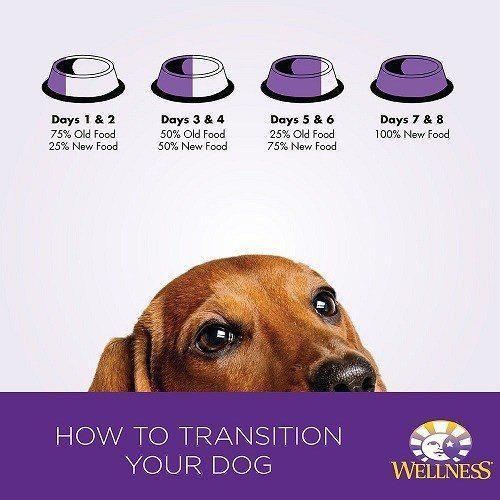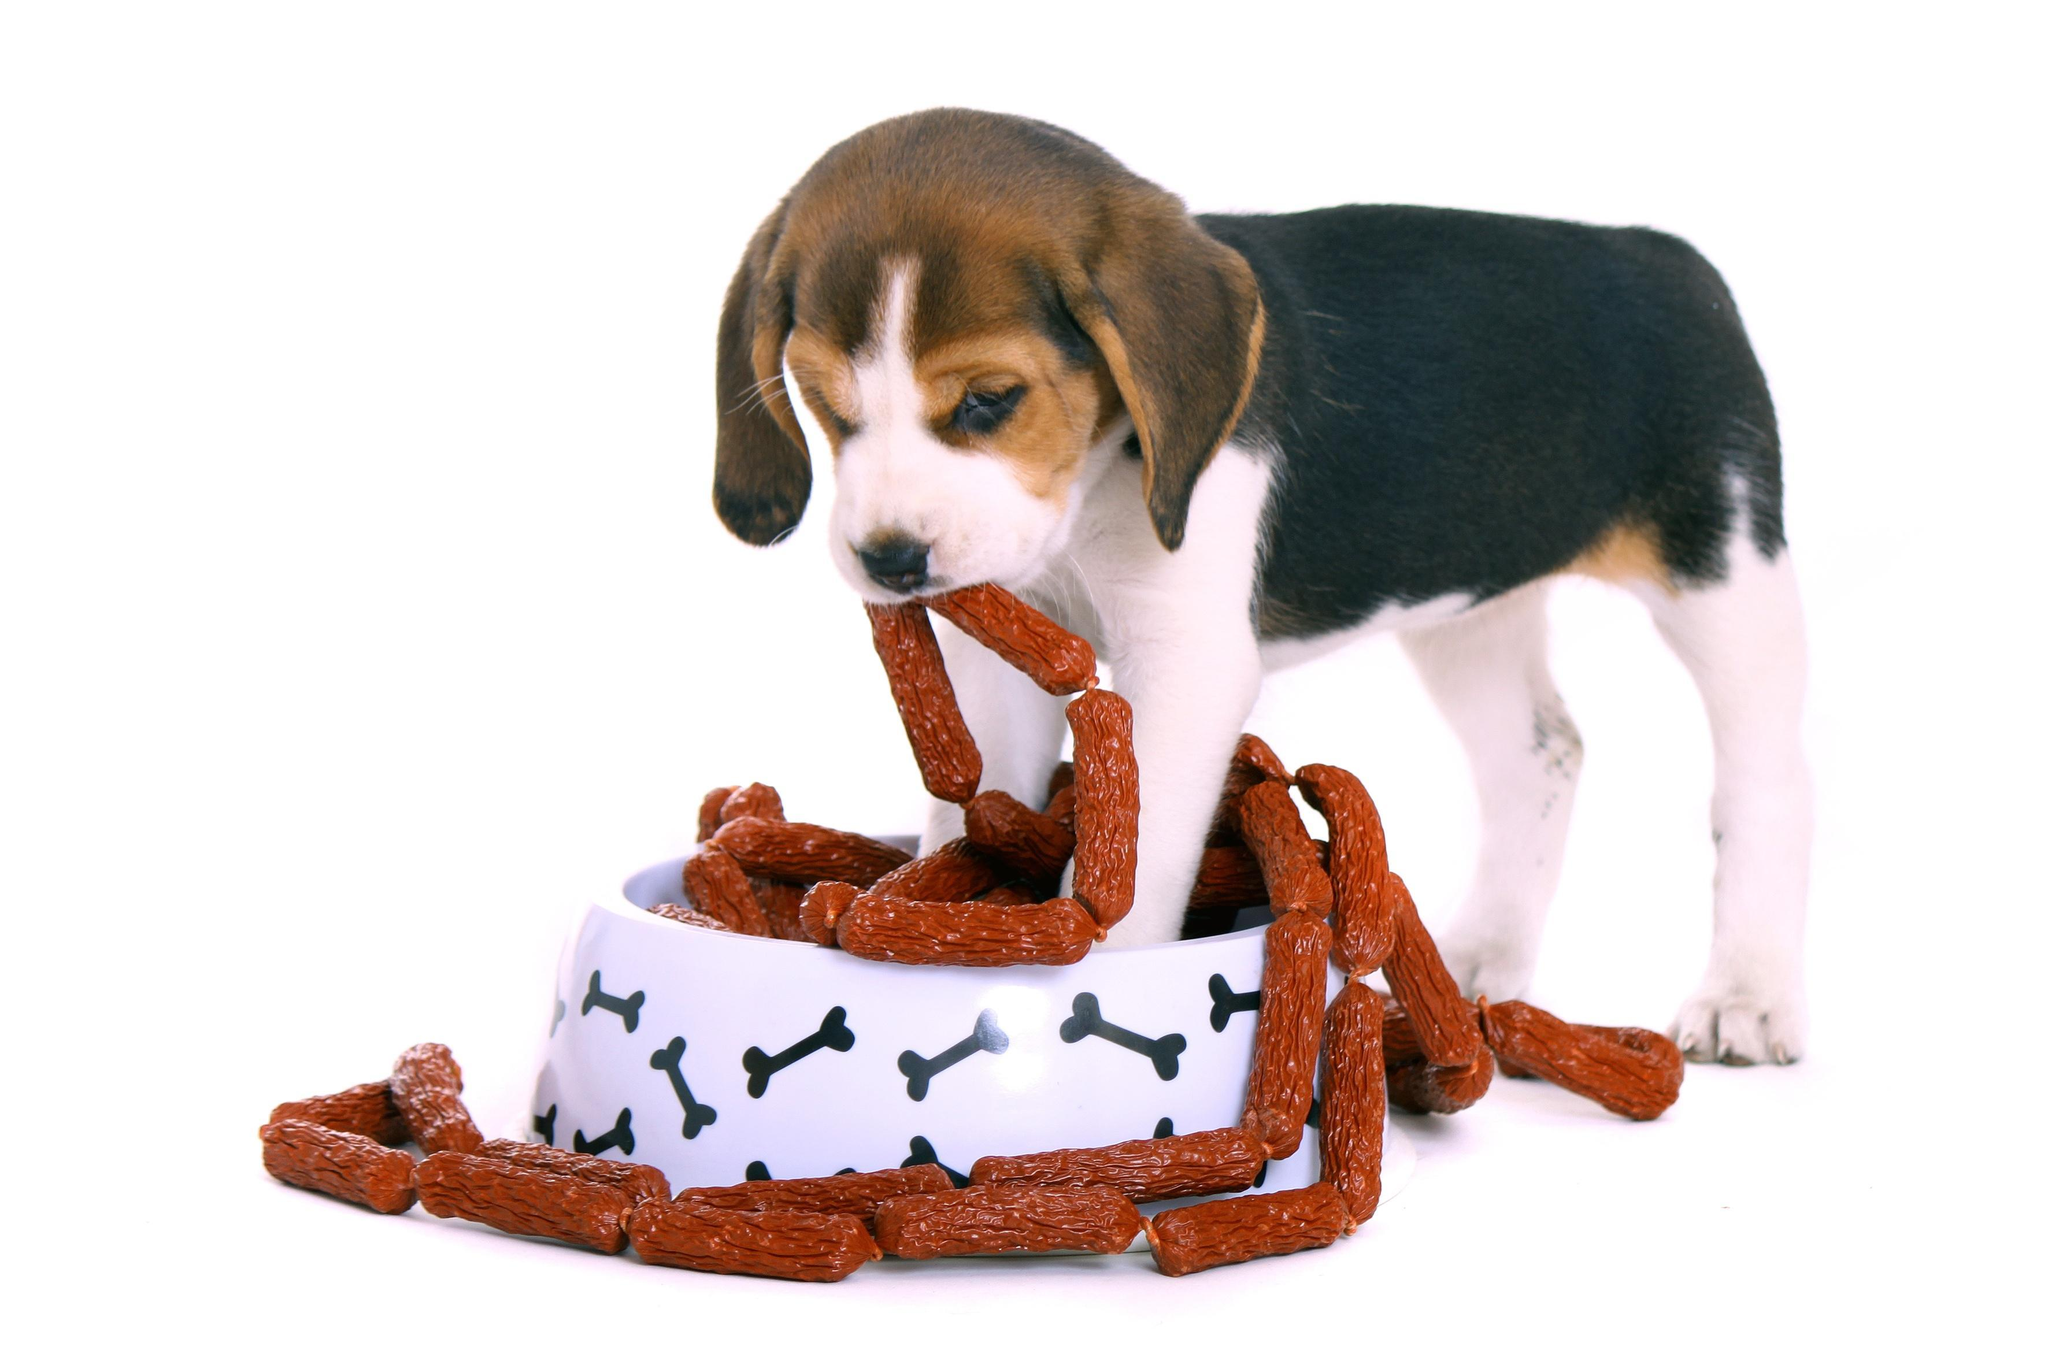The first image is the image on the left, the second image is the image on the right. Considering the images on both sides, is "A beagle is eating sausages." valid? Answer yes or no. Yes. 